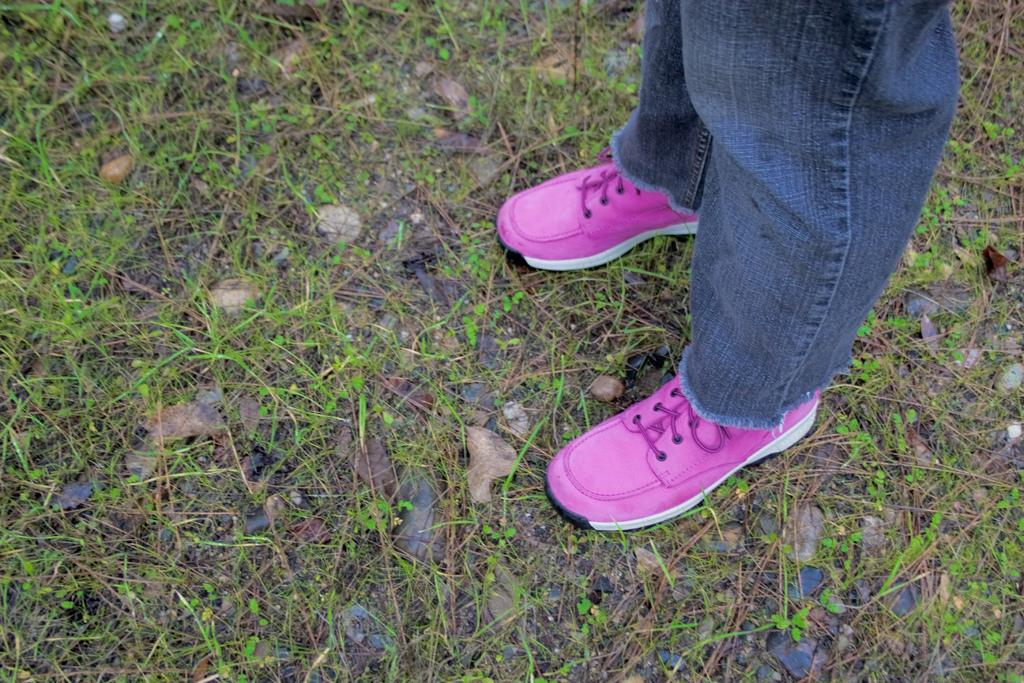What is present in the image? There is a person in the image. What is the person doing in the image? The person is standing on the ground. What type of poison is the person holding in the image? There is no poison present in the image; the person is simply standing on the ground. 